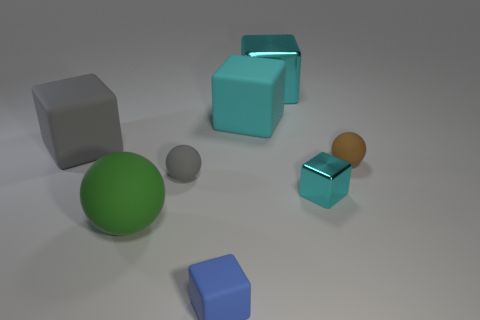Subtract all small brown balls. How many balls are left? 2 Add 2 brown rubber spheres. How many objects exist? 10 Subtract all brown spheres. How many spheres are left? 2 Subtract all spheres. How many objects are left? 5 Subtract 2 balls. How many balls are left? 1 Subtract all gray matte balls. Subtract all matte spheres. How many objects are left? 4 Add 7 small metallic cubes. How many small metallic cubes are left? 8 Add 4 small matte objects. How many small matte objects exist? 7 Subtract 0 brown blocks. How many objects are left? 8 Subtract all cyan balls. Subtract all purple blocks. How many balls are left? 3 